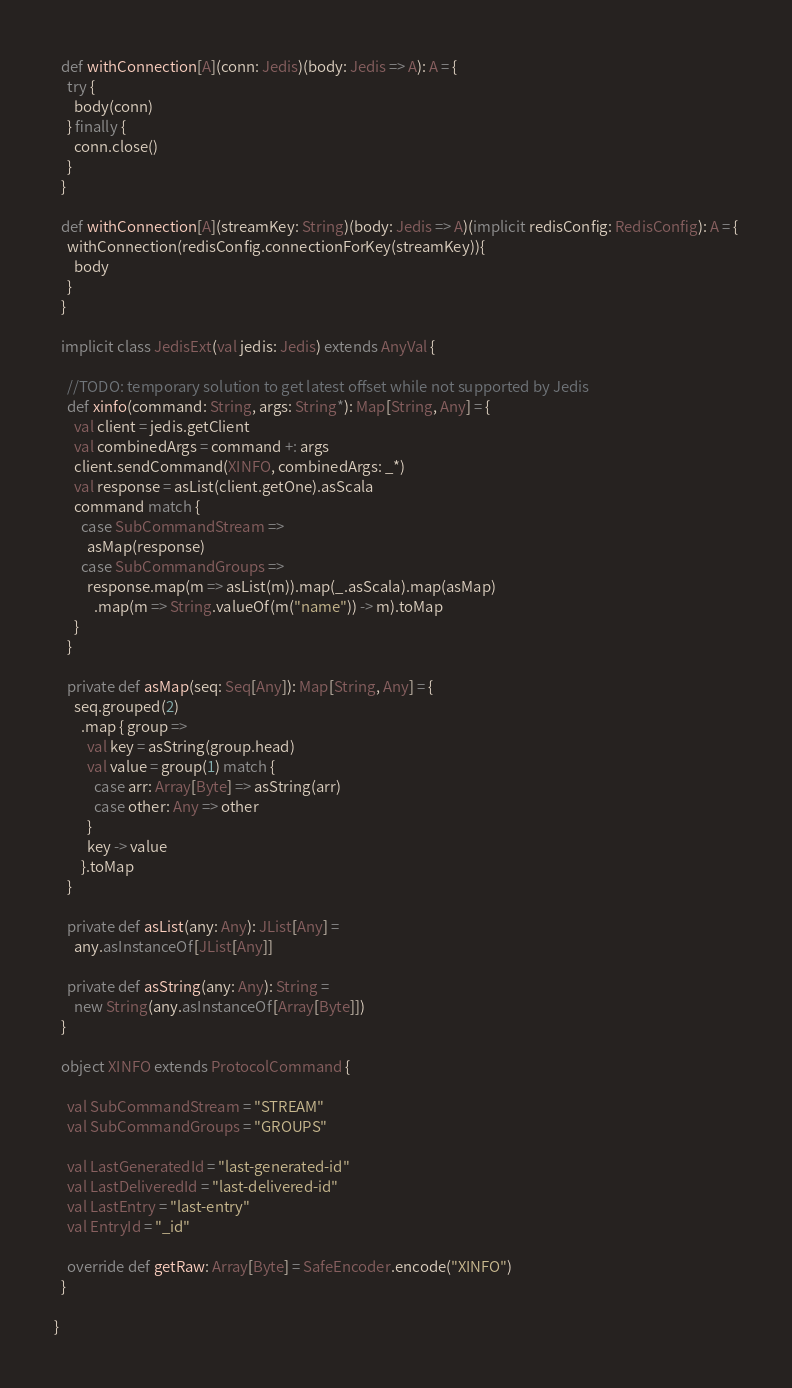Convert code to text. <code><loc_0><loc_0><loc_500><loc_500><_Scala_>  def withConnection[A](conn: Jedis)(body: Jedis => A): A = {
    try {
      body(conn)
    } finally {
      conn.close()
    }
  }

  def withConnection[A](streamKey: String)(body: Jedis => A)(implicit redisConfig: RedisConfig): A = {
    withConnection(redisConfig.connectionForKey(streamKey)){
      body
    }
  }

  implicit class JedisExt(val jedis: Jedis) extends AnyVal {

    //TODO: temporary solution to get latest offset while not supported by Jedis
    def xinfo(command: String, args: String*): Map[String, Any] = {
      val client = jedis.getClient
      val combinedArgs = command +: args
      client.sendCommand(XINFO, combinedArgs: _*)
      val response = asList(client.getOne).asScala
      command match {
        case SubCommandStream =>
          asMap(response)
        case SubCommandGroups =>
          response.map(m => asList(m)).map(_.asScala).map(asMap)
            .map(m => String.valueOf(m("name")) -> m).toMap
      }
    }

    private def asMap(seq: Seq[Any]): Map[String, Any] = {
      seq.grouped(2)
        .map { group =>
          val key = asString(group.head)
          val value = group(1) match {
            case arr: Array[Byte] => asString(arr)
            case other: Any => other
          }
          key -> value
        }.toMap
    }

    private def asList(any: Any): JList[Any] =
      any.asInstanceOf[JList[Any]]

    private def asString(any: Any): String =
      new String(any.asInstanceOf[Array[Byte]])
  }

  object XINFO extends ProtocolCommand {

    val SubCommandStream = "STREAM"
    val SubCommandGroups = "GROUPS"

    val LastGeneratedId = "last-generated-id"
    val LastDeliveredId = "last-delivered-id"
    val LastEntry = "last-entry"
    val EntryId = "_id"

    override def getRaw: Array[Byte] = SafeEncoder.encode("XINFO")
  }

}
</code> 